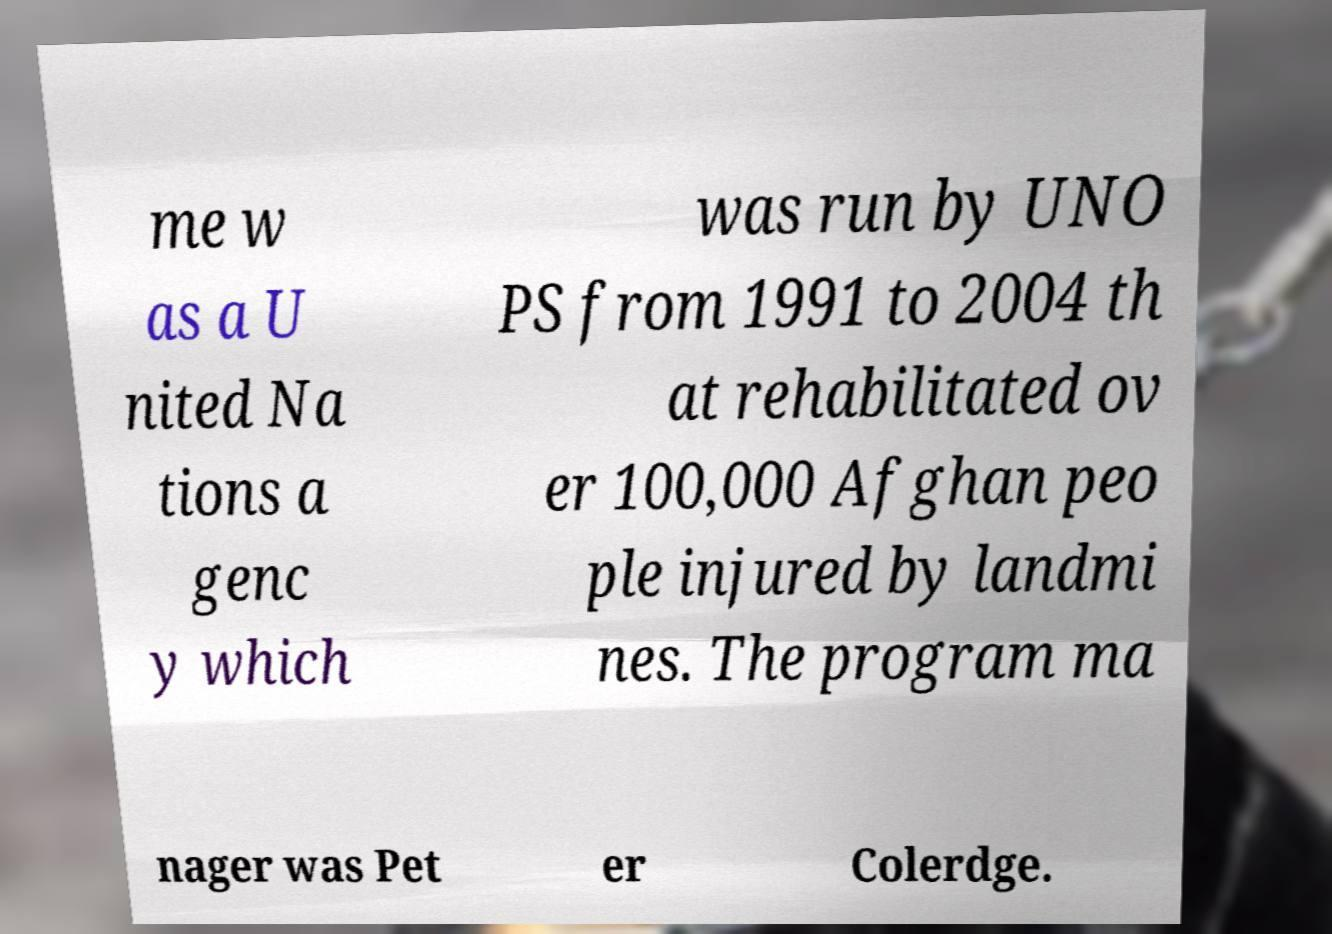I need the written content from this picture converted into text. Can you do that? me w as a U nited Na tions a genc y which was run by UNO PS from 1991 to 2004 th at rehabilitated ov er 100,000 Afghan peo ple injured by landmi nes. The program ma nager was Pet er Colerdge. 